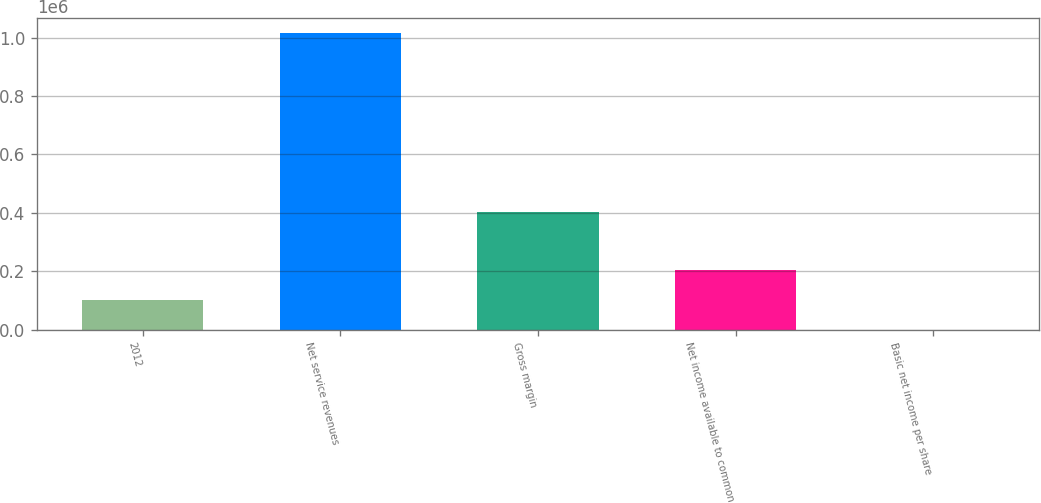Convert chart to OTSL. <chart><loc_0><loc_0><loc_500><loc_500><bar_chart><fcel>2012<fcel>Net service revenues<fcel>Gross margin<fcel>Net income available to common<fcel>Basic net income per share<nl><fcel>101545<fcel>1.01544e+06<fcel>402083<fcel>203089<fcel>0.34<nl></chart> 